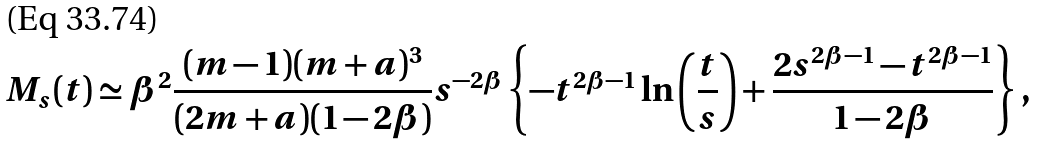<formula> <loc_0><loc_0><loc_500><loc_500>M _ { s } ( t ) \simeq \beta ^ { 2 } \frac { ( m - 1 ) ( m + a ) ^ { 3 } } { ( 2 m + a ) ( 1 - 2 \beta ) } s ^ { - 2 \beta } \left \{ - t ^ { 2 \beta - 1 } \ln \left ( \frac { t } { s } \right ) + \frac { 2 s ^ { 2 \beta - 1 } - t ^ { 2 \beta - 1 } } { 1 - 2 \beta } \right \} ,</formula> 